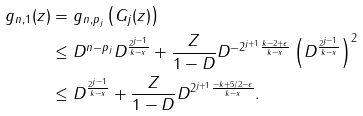<formula> <loc_0><loc_0><loc_500><loc_500>\| g _ { n , 1 } ( z ) \| & = \| g _ { n , p _ { j } } \left ( G _ { j } ( z ) \right ) \| \\ & \leq D ^ { n - p _ { j } } D ^ { \frac { 2 ^ { j - 1 } } { k - x } } + \frac { Z } { 1 - D } D ^ { - 2 ^ { j + 1 } \frac { k - 2 + \epsilon } { k - x } } \left ( D ^ { \frac { 2 ^ { j - 1 } } { k - x } } \right ) ^ { 2 } \\ & \leq D ^ { \frac { 2 ^ { j - 1 } } { k - x } } + \frac { Z } { 1 - D } D ^ { 2 ^ { j + 1 } \frac { - k + 5 / 2 - \epsilon } { k - x } } .</formula> 